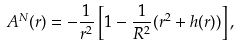<formula> <loc_0><loc_0><loc_500><loc_500>A ^ { N } ( r ) = - \frac { 1 } { r ^ { 2 } } \left [ 1 - \frac { 1 } { R ^ { 2 } } ( r ^ { 2 } + h ( r ) ) \right ] ,</formula> 